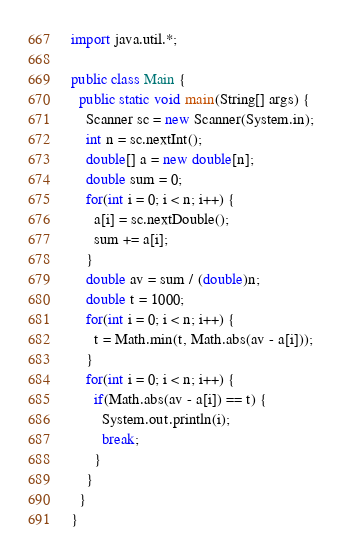Convert code to text. <code><loc_0><loc_0><loc_500><loc_500><_Java_>import java.util.*;

public class Main {
  public static void main(String[] args) {
    Scanner sc = new Scanner(System.in);
    int n = sc.nextInt();
    double[] a = new double[n];
    double sum = 0;
    for(int i = 0; i < n; i++) {
      a[i] = sc.nextDouble();
      sum += a[i];
    }
    double av = sum / (double)n;
    double t = 1000;
    for(int i = 0; i < n; i++) {
      t = Math.min(t, Math.abs(av - a[i]));
    }
    for(int i = 0; i < n; i++) {
      if(Math.abs(av - a[i]) == t) {
        System.out.println(i);
        break;
      }
    }
  }
}</code> 